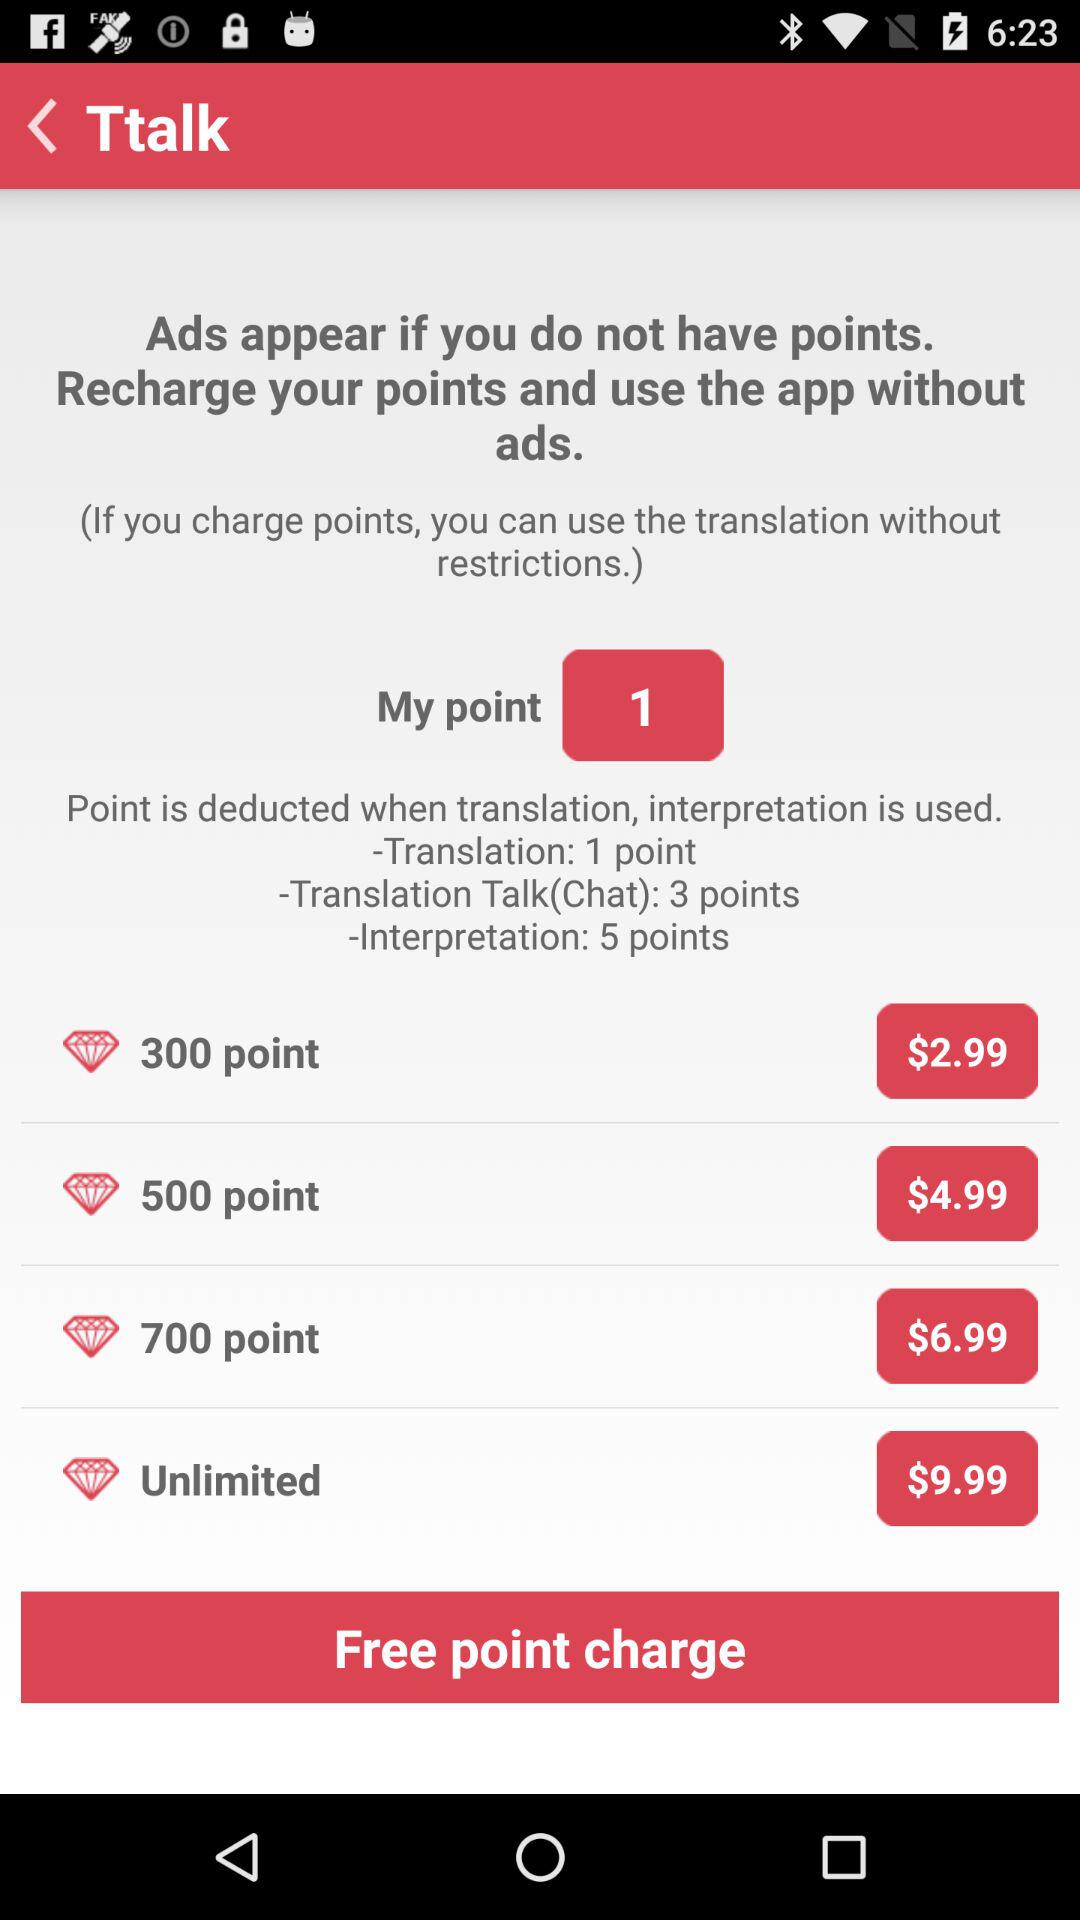How much does it cost to recharge 300 points? It costs $2.99 to recharge 300 points. 